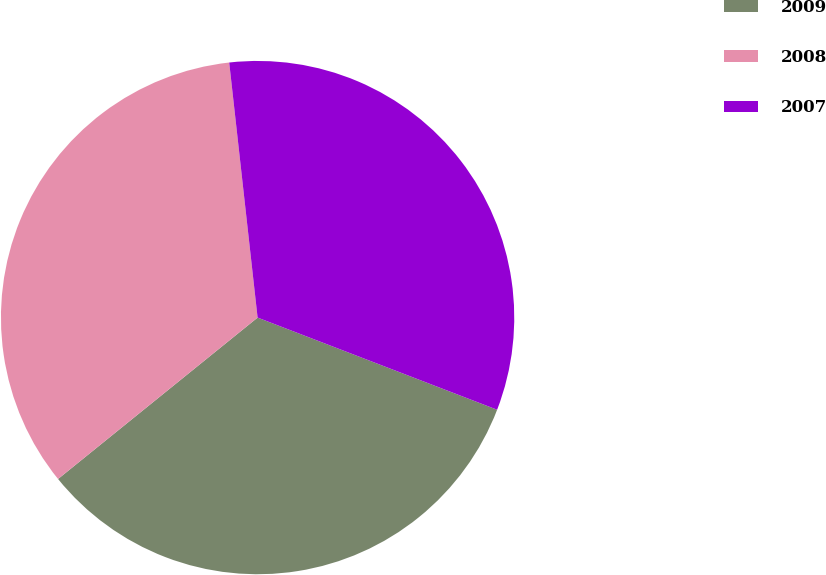Convert chart. <chart><loc_0><loc_0><loc_500><loc_500><pie_chart><fcel>2009<fcel>2008<fcel>2007<nl><fcel>33.33%<fcel>34.06%<fcel>32.61%<nl></chart> 